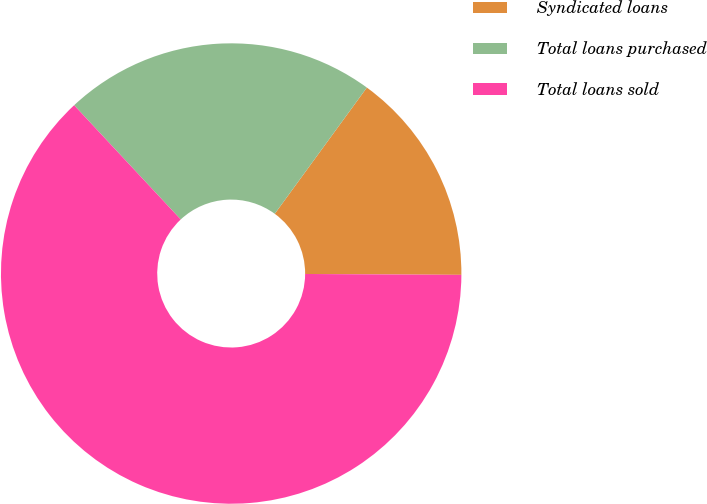Convert chart. <chart><loc_0><loc_0><loc_500><loc_500><pie_chart><fcel>Syndicated loans<fcel>Total loans purchased<fcel>Total loans sold<nl><fcel>15.06%<fcel>21.98%<fcel>62.96%<nl></chart> 